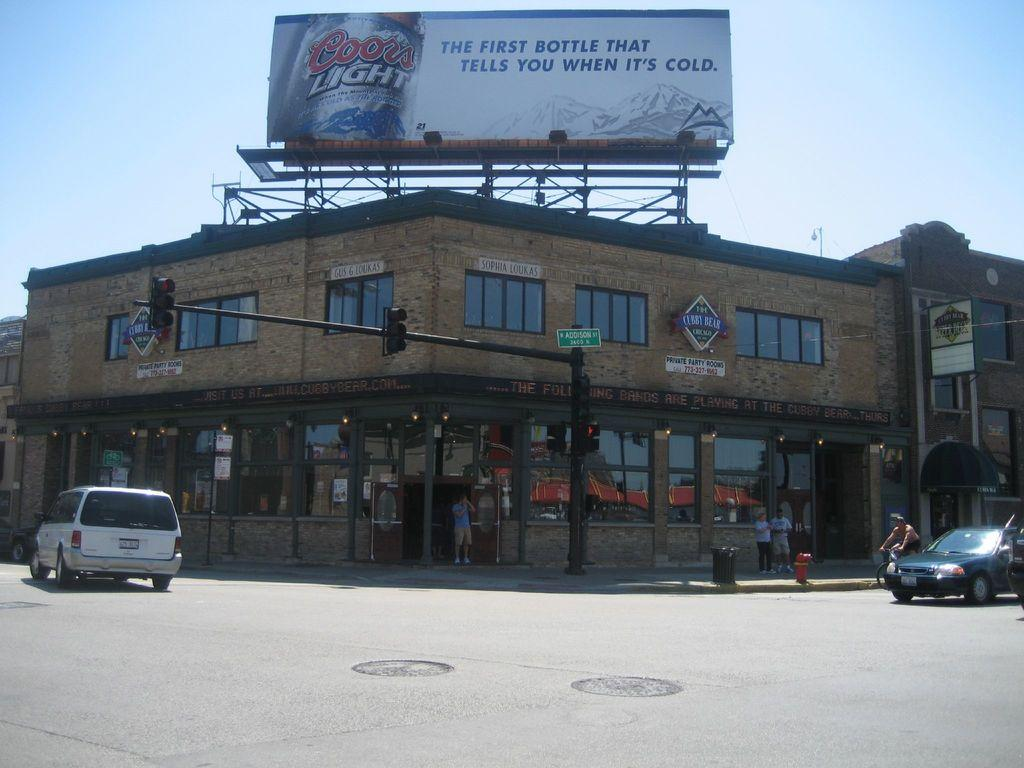<image>
Relay a brief, clear account of the picture shown. a building that is on the corner of Addison St 